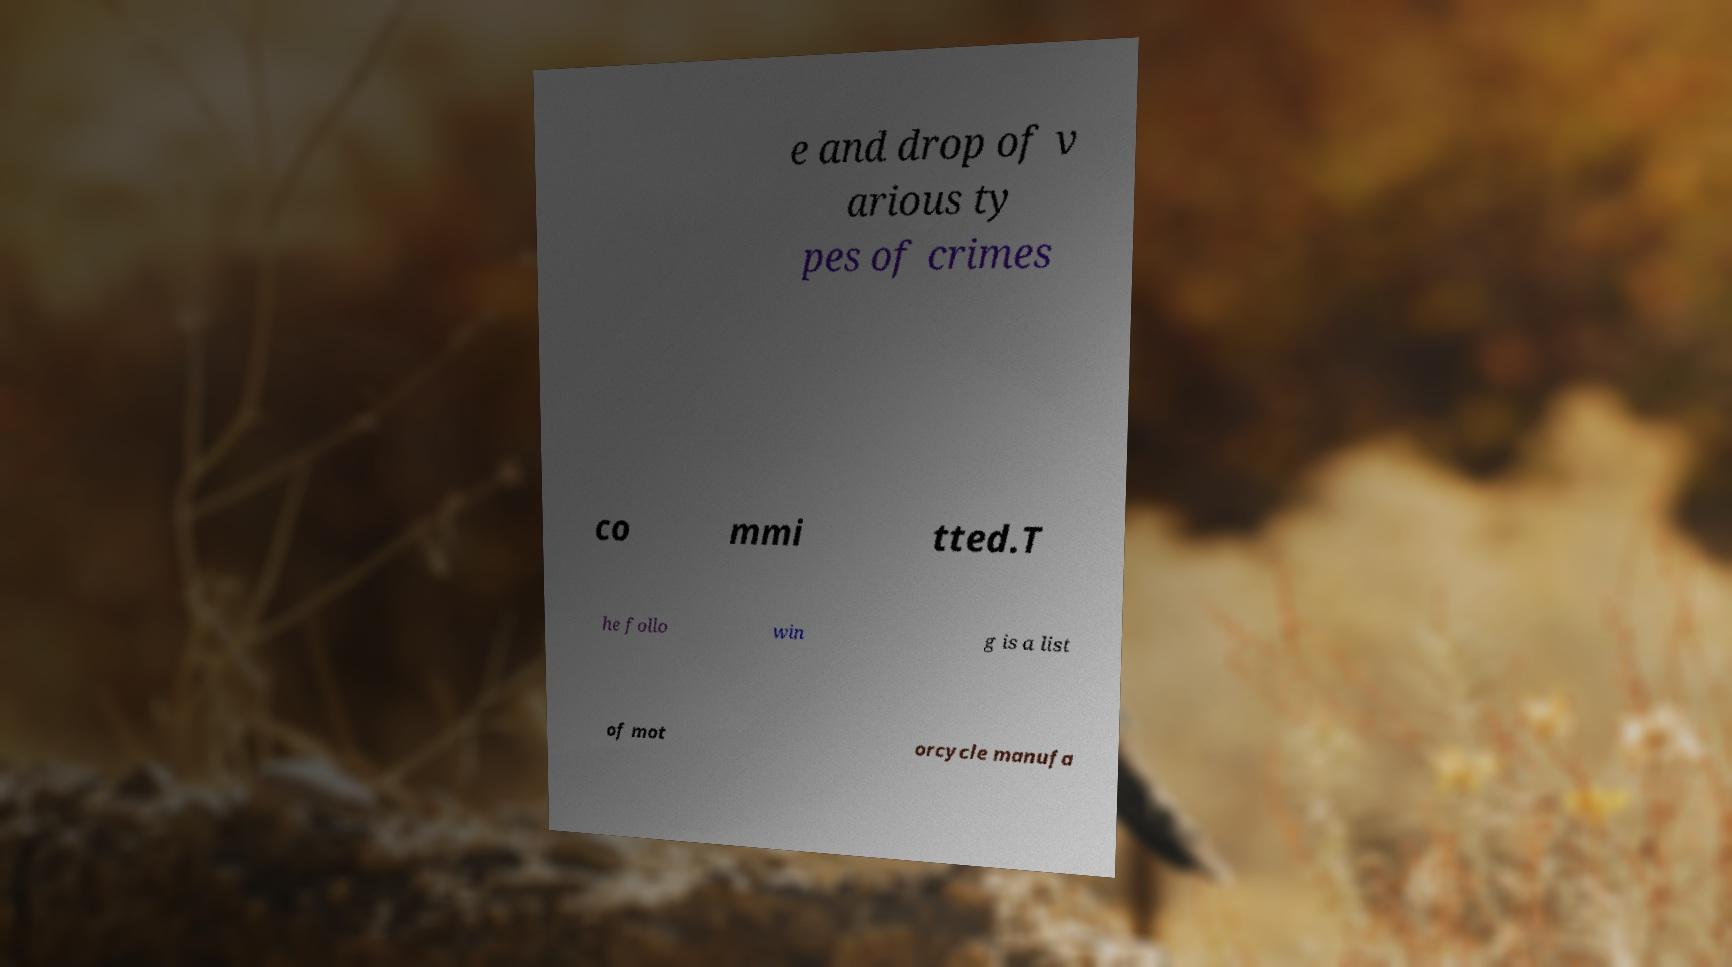I need the written content from this picture converted into text. Can you do that? e and drop of v arious ty pes of crimes co mmi tted.T he follo win g is a list of mot orcycle manufa 